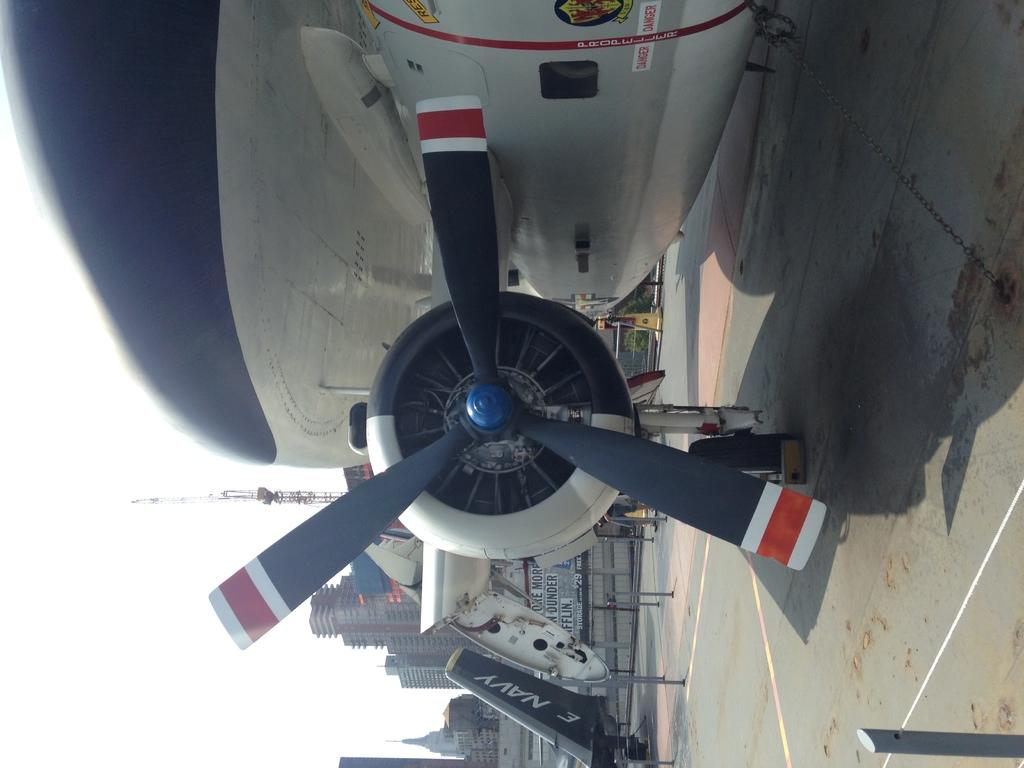<image>
Create a compact narrative representing the image presented. An airplane owned by the Navy sitting on a runway. 